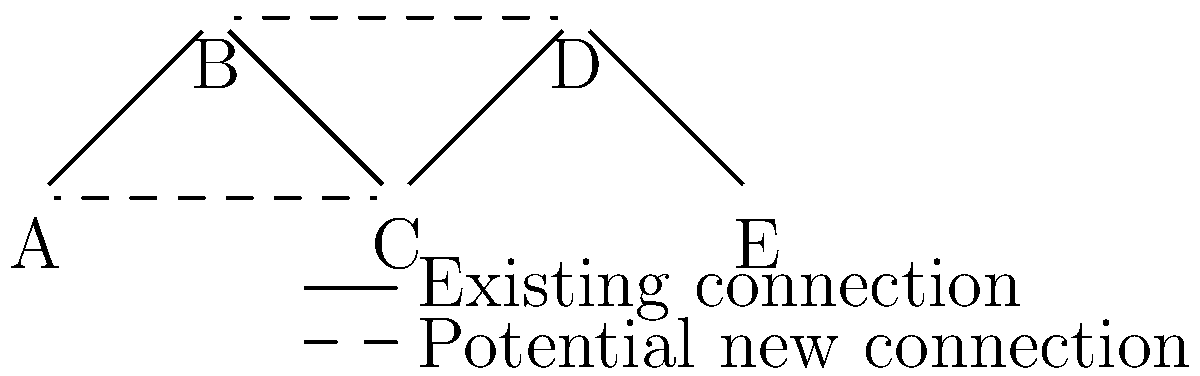In optimizing a distributed IoT system's network topology, you're considering adding new connections to improve reliability and reduce latency. The current network is represented by solid lines, while potential new connections are shown as dashed lines. If adding a new connection costs $C$ and reduces the average network latency by $L$ milliseconds, which new connection should be prioritized to maximize the return on investment (ROI) given by $\frac{L}{C}$? Assume $C_{A-C} = 100$, $L_{A-C} = 15$, $C_{B-D} = 80$, and $L_{B-D} = 10$. To determine which new connection should be prioritized, we need to calculate the ROI for each potential connection and compare them. The ROI is given by the formula $\frac{L}{C}$, where $L$ is the reduction in average network latency and $C$ is the cost of adding the connection.

Step 1: Calculate ROI for connection A-C
$ROI_{A-C} = \frac{L_{A-C}}{C_{A-C}} = \frac{15}{100} = 0.15$

Step 2: Calculate ROI for connection B-D
$ROI_{B-D} = \frac{L_{B-D}}{C_{B-D}} = \frac{10}{80} = 0.125$

Step 3: Compare the ROI values
$ROI_{A-C} (0.15) > ROI_{B-D} (0.125)$

Since the ROI for connection A-C is higher, it should be prioritized for implementation to maximize the return on investment in terms of latency reduction per unit cost.
Answer: Connection A-C 